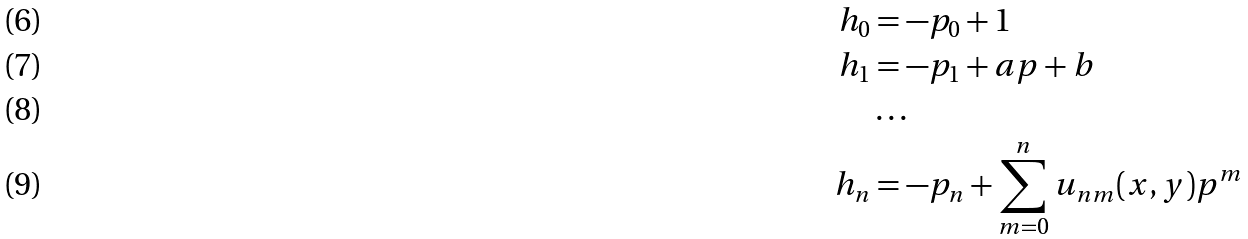Convert formula to latex. <formula><loc_0><loc_0><loc_500><loc_500>h _ { 0 } & = - p _ { 0 } + 1 \\ h _ { 1 } & = - p _ { 1 } + a p + b \\ & \dots \\ h _ { n } & = - p _ { n } + \sum _ { m = 0 } ^ { n } u _ { n m } ( x , y ) p ^ { m }</formula> 